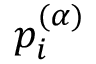Convert formula to latex. <formula><loc_0><loc_0><loc_500><loc_500>p _ { i } ^ { ( \alpha ) }</formula> 